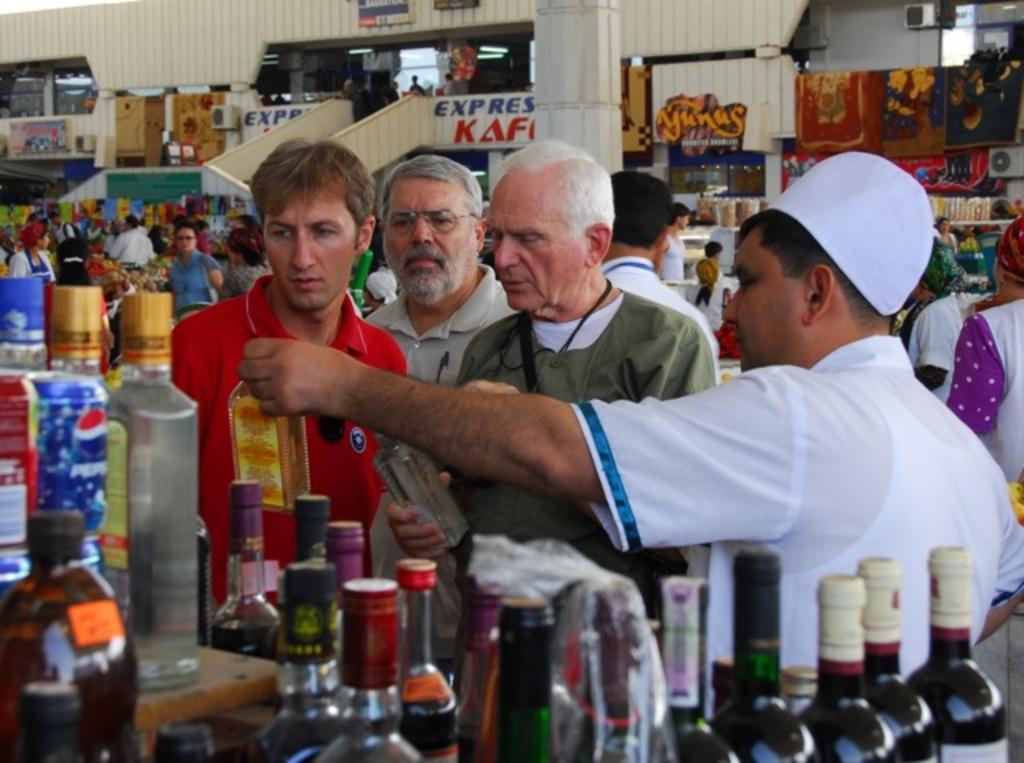Describe this image in one or two sentences. In this image I can see a market with a crowd of people and I can see four people standing in the center of the image I can see bottles at the bottom of the image.  